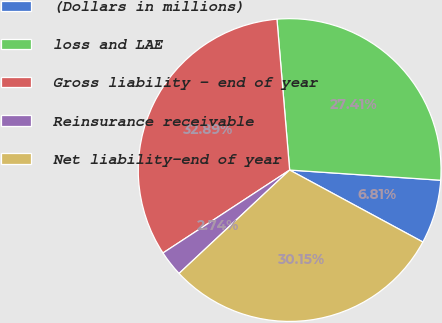Convert chart to OTSL. <chart><loc_0><loc_0><loc_500><loc_500><pie_chart><fcel>(Dollars in millions)<fcel>loss and LAE<fcel>Gross liability - end of year<fcel>Reinsurance receivable<fcel>Net liability-end of year<nl><fcel>6.81%<fcel>27.41%<fcel>32.89%<fcel>2.74%<fcel>30.15%<nl></chart> 